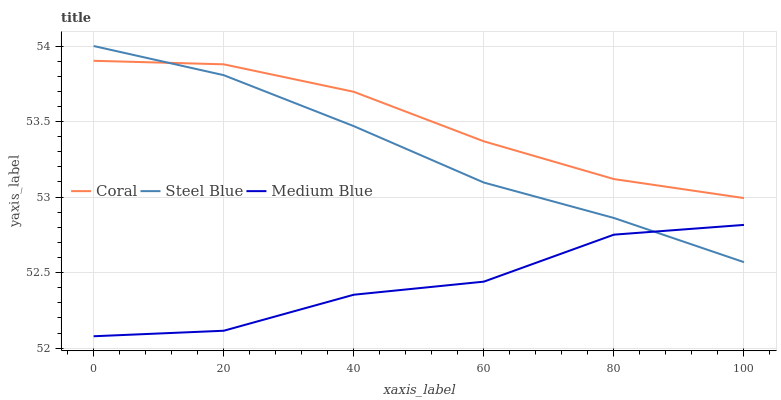Does Medium Blue have the minimum area under the curve?
Answer yes or no. Yes. Does Coral have the maximum area under the curve?
Answer yes or no. Yes. Does Steel Blue have the minimum area under the curve?
Answer yes or no. No. Does Steel Blue have the maximum area under the curve?
Answer yes or no. No. Is Steel Blue the smoothest?
Answer yes or no. Yes. Is Medium Blue the roughest?
Answer yes or no. Yes. Is Medium Blue the smoothest?
Answer yes or no. No. Is Steel Blue the roughest?
Answer yes or no. No. Does Medium Blue have the lowest value?
Answer yes or no. Yes. Does Steel Blue have the lowest value?
Answer yes or no. No. Does Steel Blue have the highest value?
Answer yes or no. Yes. Does Medium Blue have the highest value?
Answer yes or no. No. Is Medium Blue less than Coral?
Answer yes or no. Yes. Is Coral greater than Medium Blue?
Answer yes or no. Yes. Does Steel Blue intersect Medium Blue?
Answer yes or no. Yes. Is Steel Blue less than Medium Blue?
Answer yes or no. No. Is Steel Blue greater than Medium Blue?
Answer yes or no. No. Does Medium Blue intersect Coral?
Answer yes or no. No. 